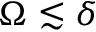<formula> <loc_0><loc_0><loc_500><loc_500>\Omega \lesssim \delta</formula> 